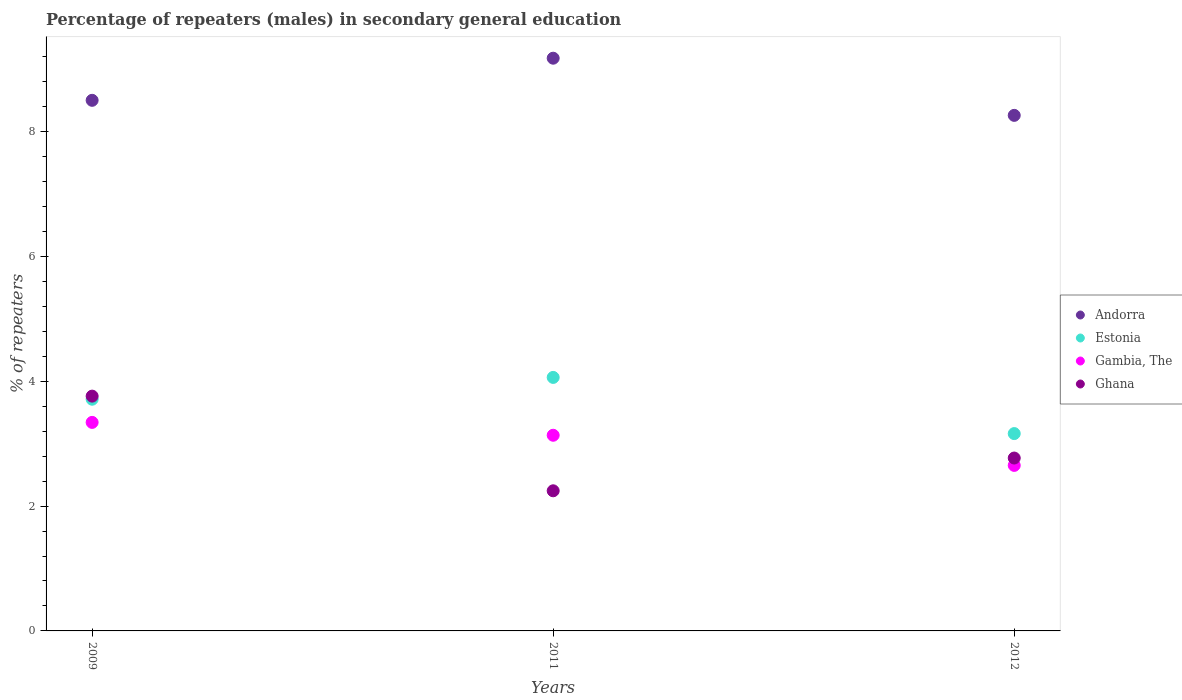How many different coloured dotlines are there?
Offer a very short reply. 4. Is the number of dotlines equal to the number of legend labels?
Provide a short and direct response. Yes. What is the percentage of male repeaters in Ghana in 2011?
Ensure brevity in your answer.  2.24. Across all years, what is the maximum percentage of male repeaters in Andorra?
Your answer should be very brief. 9.17. Across all years, what is the minimum percentage of male repeaters in Ghana?
Provide a succinct answer. 2.24. In which year was the percentage of male repeaters in Andorra minimum?
Provide a succinct answer. 2012. What is the total percentage of male repeaters in Estonia in the graph?
Provide a short and direct response. 10.93. What is the difference between the percentage of male repeaters in Ghana in 2009 and that in 2012?
Your response must be concise. 0.99. What is the difference between the percentage of male repeaters in Estonia in 2011 and the percentage of male repeaters in Andorra in 2012?
Your answer should be very brief. -4.2. What is the average percentage of male repeaters in Andorra per year?
Give a very brief answer. 8.64. In the year 2012, what is the difference between the percentage of male repeaters in Estonia and percentage of male repeaters in Andorra?
Make the answer very short. -5.1. In how many years, is the percentage of male repeaters in Gambia, The greater than 4.4 %?
Provide a short and direct response. 0. What is the ratio of the percentage of male repeaters in Gambia, The in 2011 to that in 2012?
Offer a very short reply. 1.18. Is the percentage of male repeaters in Gambia, The in 2009 less than that in 2012?
Offer a terse response. No. Is the difference between the percentage of male repeaters in Estonia in 2011 and 2012 greater than the difference between the percentage of male repeaters in Andorra in 2011 and 2012?
Offer a terse response. No. What is the difference between the highest and the second highest percentage of male repeaters in Gambia, The?
Ensure brevity in your answer.  0.21. What is the difference between the highest and the lowest percentage of male repeaters in Ghana?
Offer a very short reply. 1.52. In how many years, is the percentage of male repeaters in Gambia, The greater than the average percentage of male repeaters in Gambia, The taken over all years?
Your answer should be compact. 2. Is the sum of the percentage of male repeaters in Ghana in 2009 and 2012 greater than the maximum percentage of male repeaters in Andorra across all years?
Your answer should be very brief. No. How many dotlines are there?
Your answer should be compact. 4. How many years are there in the graph?
Give a very brief answer. 3. What is the difference between two consecutive major ticks on the Y-axis?
Your answer should be compact. 2. Does the graph contain grids?
Make the answer very short. No. Where does the legend appear in the graph?
Provide a short and direct response. Center right. How many legend labels are there?
Offer a very short reply. 4. How are the legend labels stacked?
Your response must be concise. Vertical. What is the title of the graph?
Offer a very short reply. Percentage of repeaters (males) in secondary general education. What is the label or title of the X-axis?
Make the answer very short. Years. What is the label or title of the Y-axis?
Your answer should be very brief. % of repeaters. What is the % of repeaters in Andorra in 2009?
Provide a succinct answer. 8.5. What is the % of repeaters of Estonia in 2009?
Your answer should be very brief. 3.71. What is the % of repeaters of Gambia, The in 2009?
Give a very brief answer. 3.34. What is the % of repeaters in Ghana in 2009?
Offer a terse response. 3.76. What is the % of repeaters of Andorra in 2011?
Keep it short and to the point. 9.17. What is the % of repeaters of Estonia in 2011?
Provide a succinct answer. 4.06. What is the % of repeaters in Gambia, The in 2011?
Provide a succinct answer. 3.13. What is the % of repeaters of Ghana in 2011?
Make the answer very short. 2.24. What is the % of repeaters of Andorra in 2012?
Provide a succinct answer. 8.26. What is the % of repeaters in Estonia in 2012?
Provide a short and direct response. 3.16. What is the % of repeaters in Gambia, The in 2012?
Your answer should be compact. 2.65. What is the % of repeaters of Ghana in 2012?
Provide a succinct answer. 2.77. Across all years, what is the maximum % of repeaters of Andorra?
Ensure brevity in your answer.  9.17. Across all years, what is the maximum % of repeaters in Estonia?
Your response must be concise. 4.06. Across all years, what is the maximum % of repeaters of Gambia, The?
Your answer should be compact. 3.34. Across all years, what is the maximum % of repeaters of Ghana?
Keep it short and to the point. 3.76. Across all years, what is the minimum % of repeaters of Andorra?
Offer a terse response. 8.26. Across all years, what is the minimum % of repeaters in Estonia?
Give a very brief answer. 3.16. Across all years, what is the minimum % of repeaters in Gambia, The?
Make the answer very short. 2.65. Across all years, what is the minimum % of repeaters of Ghana?
Keep it short and to the point. 2.24. What is the total % of repeaters of Andorra in the graph?
Offer a terse response. 25.93. What is the total % of repeaters of Estonia in the graph?
Offer a terse response. 10.93. What is the total % of repeaters of Gambia, The in the graph?
Your answer should be compact. 9.13. What is the total % of repeaters in Ghana in the graph?
Make the answer very short. 8.77. What is the difference between the % of repeaters of Andorra in 2009 and that in 2011?
Make the answer very short. -0.67. What is the difference between the % of repeaters in Estonia in 2009 and that in 2011?
Your answer should be very brief. -0.35. What is the difference between the % of repeaters of Gambia, The in 2009 and that in 2011?
Offer a terse response. 0.21. What is the difference between the % of repeaters of Ghana in 2009 and that in 2011?
Keep it short and to the point. 1.52. What is the difference between the % of repeaters in Andorra in 2009 and that in 2012?
Provide a short and direct response. 0.24. What is the difference between the % of repeaters in Estonia in 2009 and that in 2012?
Provide a short and direct response. 0.55. What is the difference between the % of repeaters of Gambia, The in 2009 and that in 2012?
Offer a very short reply. 0.69. What is the difference between the % of repeaters in Andorra in 2011 and that in 2012?
Your answer should be compact. 0.92. What is the difference between the % of repeaters of Estonia in 2011 and that in 2012?
Make the answer very short. 0.9. What is the difference between the % of repeaters in Gambia, The in 2011 and that in 2012?
Provide a short and direct response. 0.48. What is the difference between the % of repeaters in Ghana in 2011 and that in 2012?
Offer a terse response. -0.52. What is the difference between the % of repeaters in Andorra in 2009 and the % of repeaters in Estonia in 2011?
Ensure brevity in your answer.  4.44. What is the difference between the % of repeaters of Andorra in 2009 and the % of repeaters of Gambia, The in 2011?
Offer a very short reply. 5.37. What is the difference between the % of repeaters of Andorra in 2009 and the % of repeaters of Ghana in 2011?
Give a very brief answer. 6.25. What is the difference between the % of repeaters of Estonia in 2009 and the % of repeaters of Gambia, The in 2011?
Offer a very short reply. 0.58. What is the difference between the % of repeaters in Estonia in 2009 and the % of repeaters in Ghana in 2011?
Your response must be concise. 1.47. What is the difference between the % of repeaters of Gambia, The in 2009 and the % of repeaters of Ghana in 2011?
Your answer should be very brief. 1.1. What is the difference between the % of repeaters in Andorra in 2009 and the % of repeaters in Estonia in 2012?
Keep it short and to the point. 5.34. What is the difference between the % of repeaters in Andorra in 2009 and the % of repeaters in Gambia, The in 2012?
Your answer should be very brief. 5.85. What is the difference between the % of repeaters in Andorra in 2009 and the % of repeaters in Ghana in 2012?
Your answer should be very brief. 5.73. What is the difference between the % of repeaters in Estonia in 2009 and the % of repeaters in Gambia, The in 2012?
Give a very brief answer. 1.06. What is the difference between the % of repeaters in Estonia in 2009 and the % of repeaters in Ghana in 2012?
Your answer should be compact. 0.94. What is the difference between the % of repeaters of Gambia, The in 2009 and the % of repeaters of Ghana in 2012?
Your answer should be very brief. 0.57. What is the difference between the % of repeaters in Andorra in 2011 and the % of repeaters in Estonia in 2012?
Provide a succinct answer. 6.01. What is the difference between the % of repeaters in Andorra in 2011 and the % of repeaters in Gambia, The in 2012?
Provide a succinct answer. 6.52. What is the difference between the % of repeaters of Andorra in 2011 and the % of repeaters of Ghana in 2012?
Keep it short and to the point. 6.4. What is the difference between the % of repeaters in Estonia in 2011 and the % of repeaters in Gambia, The in 2012?
Your answer should be very brief. 1.41. What is the difference between the % of repeaters of Estonia in 2011 and the % of repeaters of Ghana in 2012?
Offer a very short reply. 1.29. What is the difference between the % of repeaters of Gambia, The in 2011 and the % of repeaters of Ghana in 2012?
Your answer should be compact. 0.36. What is the average % of repeaters of Andorra per year?
Your answer should be compact. 8.64. What is the average % of repeaters in Estonia per year?
Your answer should be very brief. 3.64. What is the average % of repeaters of Gambia, The per year?
Offer a terse response. 3.04. What is the average % of repeaters of Ghana per year?
Make the answer very short. 2.92. In the year 2009, what is the difference between the % of repeaters of Andorra and % of repeaters of Estonia?
Ensure brevity in your answer.  4.79. In the year 2009, what is the difference between the % of repeaters in Andorra and % of repeaters in Gambia, The?
Your answer should be compact. 5.16. In the year 2009, what is the difference between the % of repeaters of Andorra and % of repeaters of Ghana?
Give a very brief answer. 4.74. In the year 2009, what is the difference between the % of repeaters of Estonia and % of repeaters of Gambia, The?
Make the answer very short. 0.37. In the year 2009, what is the difference between the % of repeaters in Estonia and % of repeaters in Ghana?
Offer a terse response. -0.05. In the year 2009, what is the difference between the % of repeaters in Gambia, The and % of repeaters in Ghana?
Ensure brevity in your answer.  -0.42. In the year 2011, what is the difference between the % of repeaters in Andorra and % of repeaters in Estonia?
Your answer should be compact. 5.11. In the year 2011, what is the difference between the % of repeaters of Andorra and % of repeaters of Gambia, The?
Ensure brevity in your answer.  6.04. In the year 2011, what is the difference between the % of repeaters in Andorra and % of repeaters in Ghana?
Your answer should be compact. 6.93. In the year 2011, what is the difference between the % of repeaters of Estonia and % of repeaters of Gambia, The?
Your answer should be compact. 0.93. In the year 2011, what is the difference between the % of repeaters in Estonia and % of repeaters in Ghana?
Keep it short and to the point. 1.82. In the year 2011, what is the difference between the % of repeaters in Gambia, The and % of repeaters in Ghana?
Offer a very short reply. 0.89. In the year 2012, what is the difference between the % of repeaters in Andorra and % of repeaters in Estonia?
Provide a short and direct response. 5.1. In the year 2012, what is the difference between the % of repeaters in Andorra and % of repeaters in Gambia, The?
Provide a short and direct response. 5.61. In the year 2012, what is the difference between the % of repeaters of Andorra and % of repeaters of Ghana?
Offer a very short reply. 5.49. In the year 2012, what is the difference between the % of repeaters in Estonia and % of repeaters in Gambia, The?
Offer a very short reply. 0.51. In the year 2012, what is the difference between the % of repeaters of Estonia and % of repeaters of Ghana?
Ensure brevity in your answer.  0.39. In the year 2012, what is the difference between the % of repeaters of Gambia, The and % of repeaters of Ghana?
Your answer should be compact. -0.12. What is the ratio of the % of repeaters of Andorra in 2009 to that in 2011?
Your answer should be very brief. 0.93. What is the ratio of the % of repeaters in Estonia in 2009 to that in 2011?
Offer a terse response. 0.91. What is the ratio of the % of repeaters of Gambia, The in 2009 to that in 2011?
Keep it short and to the point. 1.07. What is the ratio of the % of repeaters in Ghana in 2009 to that in 2011?
Make the answer very short. 1.68. What is the ratio of the % of repeaters in Andorra in 2009 to that in 2012?
Ensure brevity in your answer.  1.03. What is the ratio of the % of repeaters of Estonia in 2009 to that in 2012?
Ensure brevity in your answer.  1.17. What is the ratio of the % of repeaters in Gambia, The in 2009 to that in 2012?
Your response must be concise. 1.26. What is the ratio of the % of repeaters in Ghana in 2009 to that in 2012?
Your answer should be compact. 1.36. What is the ratio of the % of repeaters in Andorra in 2011 to that in 2012?
Give a very brief answer. 1.11. What is the ratio of the % of repeaters of Estonia in 2011 to that in 2012?
Your answer should be very brief. 1.28. What is the ratio of the % of repeaters in Gambia, The in 2011 to that in 2012?
Keep it short and to the point. 1.18. What is the ratio of the % of repeaters in Ghana in 2011 to that in 2012?
Offer a very short reply. 0.81. What is the difference between the highest and the second highest % of repeaters of Andorra?
Keep it short and to the point. 0.67. What is the difference between the highest and the second highest % of repeaters of Estonia?
Ensure brevity in your answer.  0.35. What is the difference between the highest and the second highest % of repeaters in Gambia, The?
Keep it short and to the point. 0.21. What is the difference between the highest and the lowest % of repeaters in Andorra?
Give a very brief answer. 0.92. What is the difference between the highest and the lowest % of repeaters in Estonia?
Ensure brevity in your answer.  0.9. What is the difference between the highest and the lowest % of repeaters in Gambia, The?
Provide a succinct answer. 0.69. What is the difference between the highest and the lowest % of repeaters of Ghana?
Give a very brief answer. 1.52. 